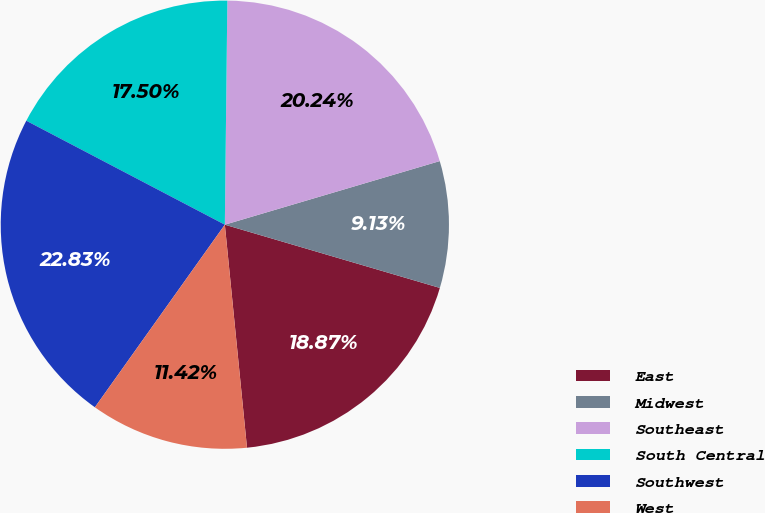Convert chart to OTSL. <chart><loc_0><loc_0><loc_500><loc_500><pie_chart><fcel>East<fcel>Midwest<fcel>Southeast<fcel>South Central<fcel>Southwest<fcel>West<nl><fcel>18.87%<fcel>9.13%<fcel>20.24%<fcel>17.5%<fcel>22.83%<fcel>11.42%<nl></chart> 